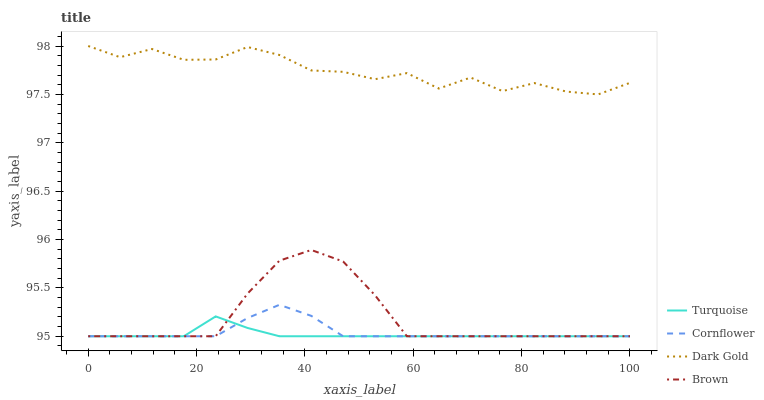Does Turquoise have the minimum area under the curve?
Answer yes or no. Yes. Does Dark Gold have the maximum area under the curve?
Answer yes or no. Yes. Does Brown have the minimum area under the curve?
Answer yes or no. No. Does Brown have the maximum area under the curve?
Answer yes or no. No. Is Turquoise the smoothest?
Answer yes or no. Yes. Is Dark Gold the roughest?
Answer yes or no. Yes. Is Brown the smoothest?
Answer yes or no. No. Is Brown the roughest?
Answer yes or no. No. Does Cornflower have the lowest value?
Answer yes or no. Yes. Does Dark Gold have the lowest value?
Answer yes or no. No. Does Dark Gold have the highest value?
Answer yes or no. Yes. Does Brown have the highest value?
Answer yes or no. No. Is Brown less than Dark Gold?
Answer yes or no. Yes. Is Dark Gold greater than Cornflower?
Answer yes or no. Yes. Does Turquoise intersect Cornflower?
Answer yes or no. Yes. Is Turquoise less than Cornflower?
Answer yes or no. No. Is Turquoise greater than Cornflower?
Answer yes or no. No. Does Brown intersect Dark Gold?
Answer yes or no. No. 